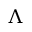Convert formula to latex. <formula><loc_0><loc_0><loc_500><loc_500>\Lambda</formula> 